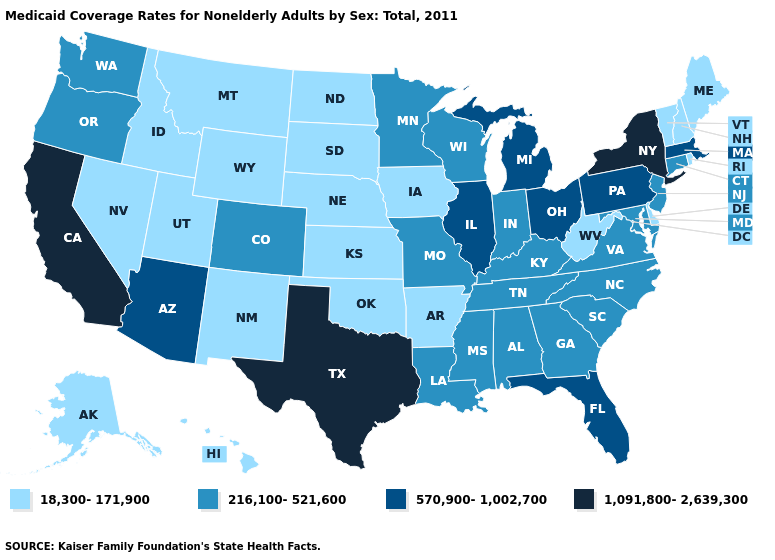Among the states that border Kansas , which have the lowest value?
Answer briefly. Nebraska, Oklahoma. Which states have the lowest value in the MidWest?
Concise answer only. Iowa, Kansas, Nebraska, North Dakota, South Dakota. Among the states that border Nebraska , which have the lowest value?
Concise answer only. Iowa, Kansas, South Dakota, Wyoming. Which states hav the highest value in the South?
Keep it brief. Texas. What is the value of Ohio?
Write a very short answer. 570,900-1,002,700. Does Delaware have a lower value than Iowa?
Short answer required. No. Among the states that border West Virginia , which have the highest value?
Write a very short answer. Ohio, Pennsylvania. Name the states that have a value in the range 216,100-521,600?
Be succinct. Alabama, Colorado, Connecticut, Georgia, Indiana, Kentucky, Louisiana, Maryland, Minnesota, Mississippi, Missouri, New Jersey, North Carolina, Oregon, South Carolina, Tennessee, Virginia, Washington, Wisconsin. Among the states that border Florida , which have the highest value?
Answer briefly. Alabama, Georgia. What is the lowest value in the South?
Be succinct. 18,300-171,900. Does the map have missing data?
Give a very brief answer. No. Name the states that have a value in the range 570,900-1,002,700?
Short answer required. Arizona, Florida, Illinois, Massachusetts, Michigan, Ohio, Pennsylvania. Name the states that have a value in the range 570,900-1,002,700?
Give a very brief answer. Arizona, Florida, Illinois, Massachusetts, Michigan, Ohio, Pennsylvania. Does Virginia have a higher value than Oregon?
Give a very brief answer. No. Name the states that have a value in the range 18,300-171,900?
Give a very brief answer. Alaska, Arkansas, Delaware, Hawaii, Idaho, Iowa, Kansas, Maine, Montana, Nebraska, Nevada, New Hampshire, New Mexico, North Dakota, Oklahoma, Rhode Island, South Dakota, Utah, Vermont, West Virginia, Wyoming. 